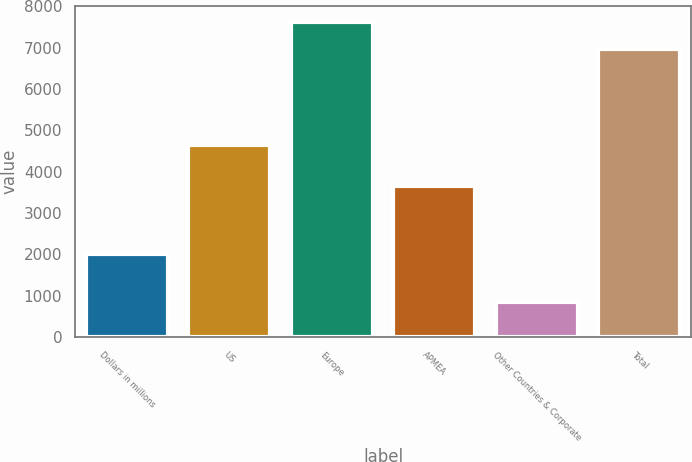Convert chart to OTSL. <chart><loc_0><loc_0><loc_500><loc_500><bar_chart><fcel>Dollars in millions<fcel>US<fcel>Europe<fcel>APMEA<fcel>Other Countries & Corporate<fcel>Total<nl><fcel>2008<fcel>4636<fcel>7619.3<fcel>3660<fcel>841<fcel>6961<nl></chart> 